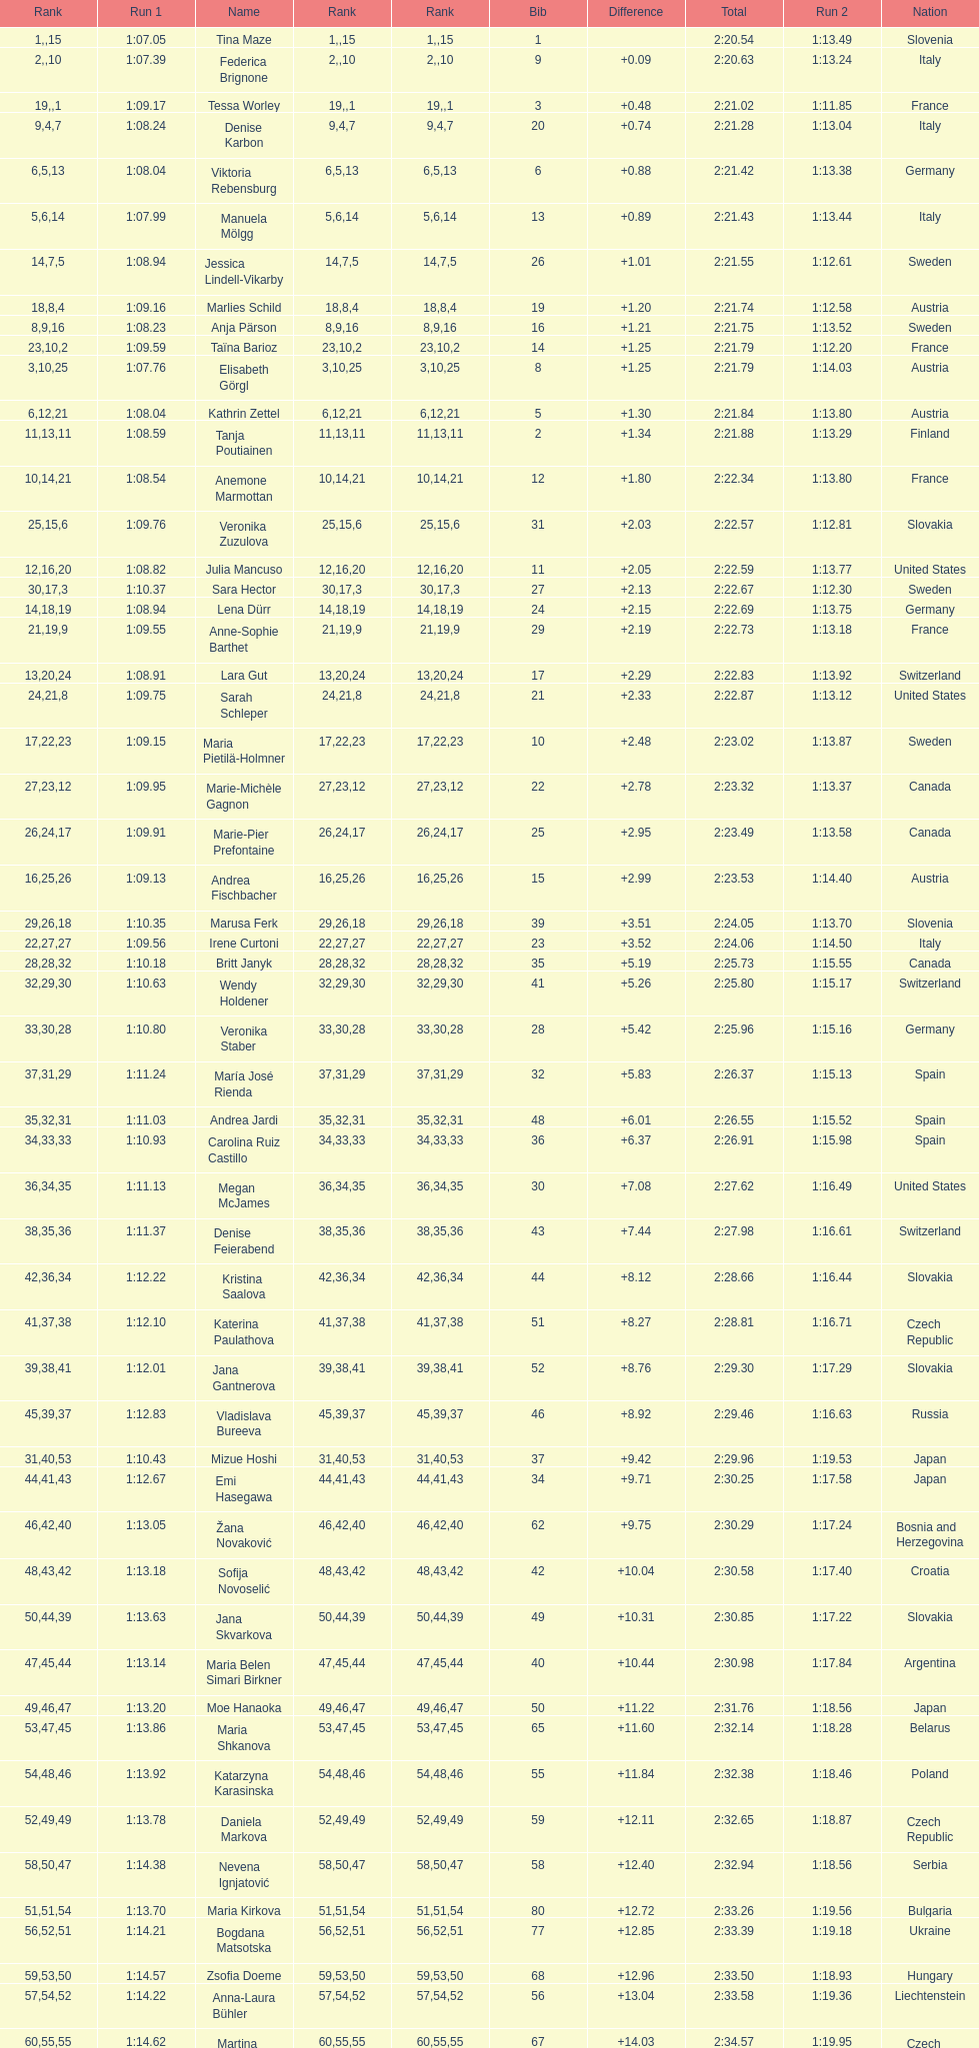Who was the last competitor to actually finish both runs? Martina Dubovska. 